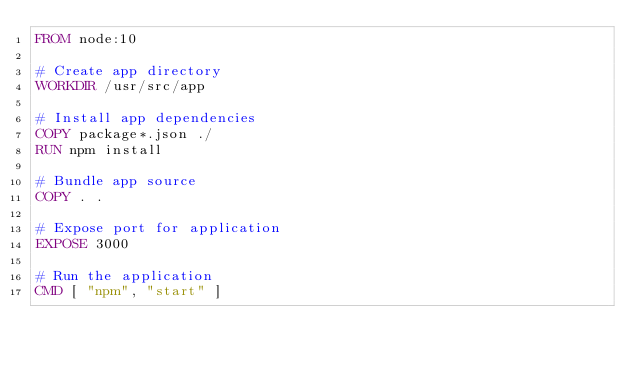<code> <loc_0><loc_0><loc_500><loc_500><_Dockerfile_>FROM node:10

# Create app directory
WORKDIR /usr/src/app

# Install app dependencies
COPY package*.json ./
RUN npm install

# Bundle app source
COPY . .

# Expose port for application
EXPOSE 3000

# Run the application
CMD [ "npm", "start" ]

</code> 